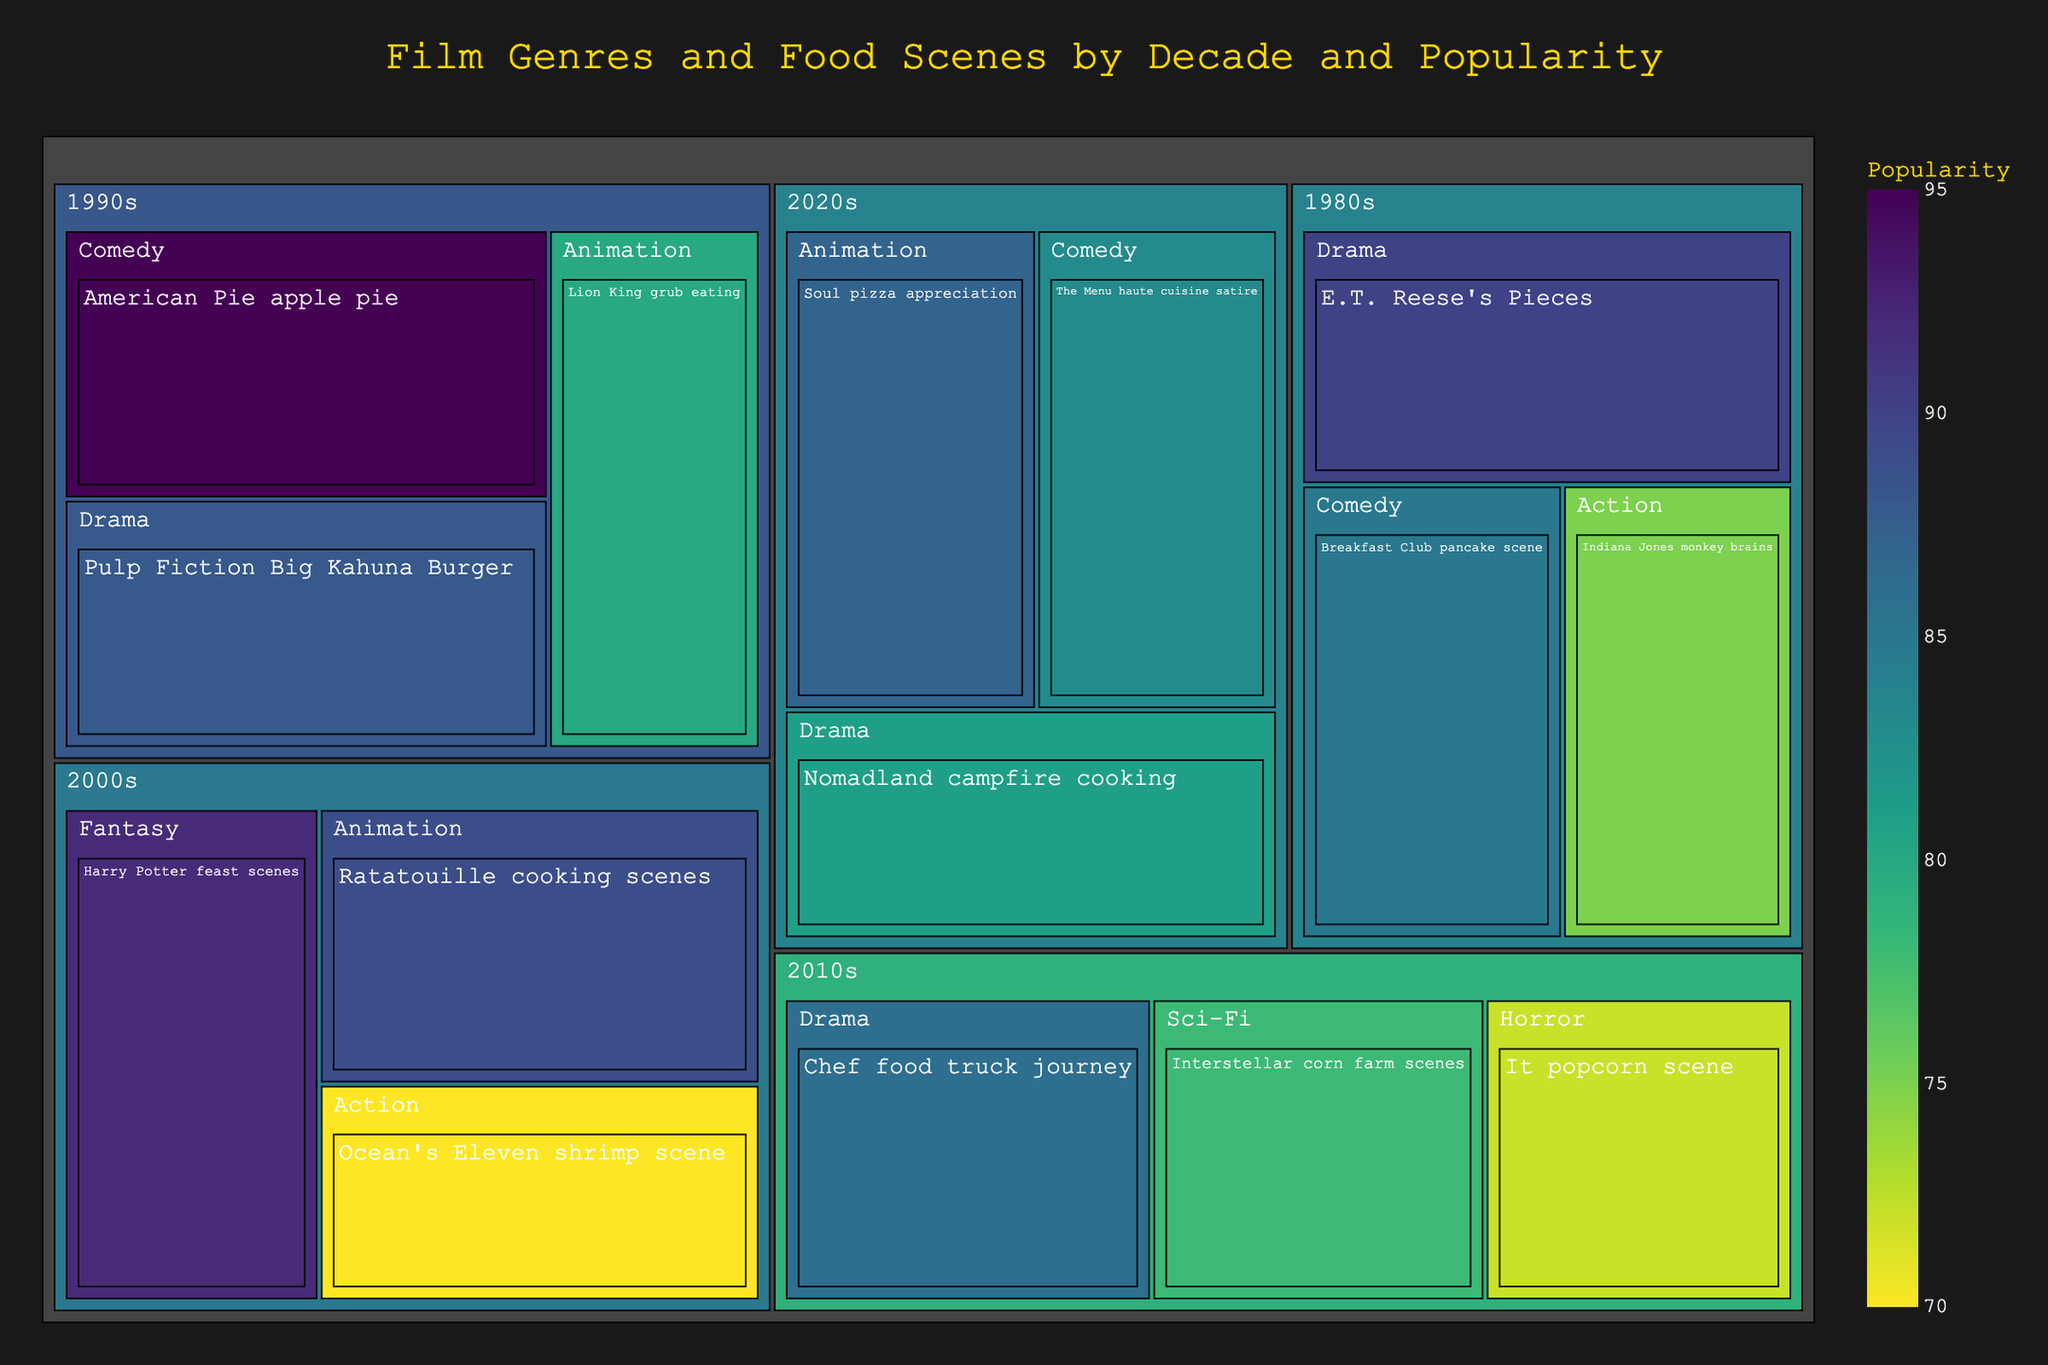Which decade features the most popular food scene in Comedy genre? Look for the highest popularity value within the Comedy genre for each decade. The Breakfast Club pancake scene in the 1980s has a popularity of 85, American Pie apple pie scene in the 1990s has 95, and The Menu haute cuisine satire in the 2020s has 83.
Answer: 1990s Which Animation film food scene has the least popularity? Compare the popularity values of the food scenes in the Animation genre. Lion King grub eating from the 1990s has 80, Ratatouille cooking scenes from the 2000s have 89, and Soul pizza appreciation from the 2020s has 87. The 1990s' Lion King grub eating has the lowest at 80.
Answer: Lion King grub eating How does the popularity of the E.T. Reese's Pieces scene compare to the Nomadland campfire cooking scene? Compare the popularity values of the scenes. E.T. Reese's Pieces scene from the 1980s has a popularity of 90, whereas Nomadland campfire cooking scene from the 2020s has a popularity of 81. 90 is greater than 81.
Answer: Higher What's the average popularity of the scenes from the 2010s? Add up the popularity values of scenes from the 2010s and divide by the number of scenes. (78 for Interstellar corn farm, 86 for Chef food truck journey, 72 for It popcorn). (78 + 86 + 72)/3 = 236/3 = 78.67
Answer: 78.67 Which Drama film food scene has the highest popularity? Compare the popularity values of the food scenes in the Drama genre. E.T. Reese's Pieces has 90, Pulp Fiction Big Kahuna Burger has 88, Chef food truck journey has 86, and Nomadland campfire cooking has 81. The E.T. Reese's Pieces scene has the highest popularity at 90.
Answer: E.T. Reese's Pieces What's the difference in popularity between Ocean's Eleven shrimp scene and Ratatouille cooking scenes? Compare the popularity values of the scenes. Ocean's Eleven shrimp scene from the 2000s has a popularity of 70, whereas Ratatouille cooking scenes from the 2000s have a popularity of 89. The difference is 89 - 70 = 19.
Answer: 19 Which genre has the most food scenes featured in the 2000s decade? Check the food scenes number for each genre in the 2000s. Fantasy has 1 (Harry Potter feast scenes), Animation has 1 (Ratatouille cooking scenes), and Action has 1 (Ocean's Eleven shrimp scene). Each genre has hosted one food scene.
Answer: All with 1 